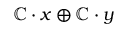Convert formula to latex. <formula><loc_0><loc_0><loc_500><loc_500>\mathbb { C } \cdot x \oplus \mathbb { C } \cdot y</formula> 